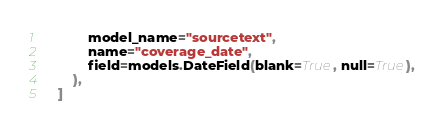<code> <loc_0><loc_0><loc_500><loc_500><_Python_>            model_name="sourcetext",
            name="coverage_date",
            field=models.DateField(blank=True, null=True),
        ),
    ]
</code> 